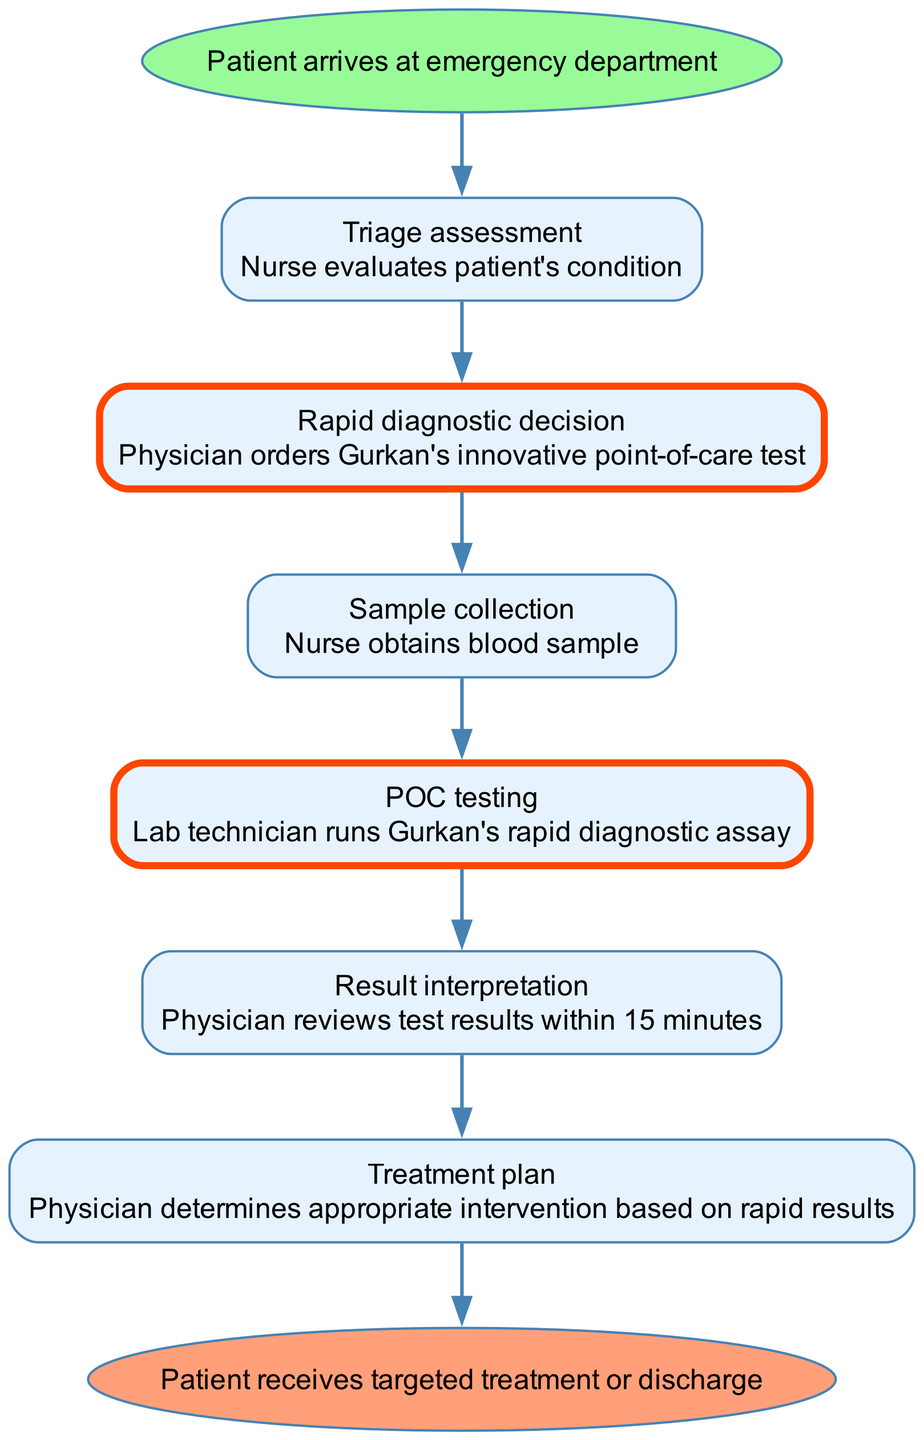What is the first step in the clinical pathway? The first step listed in the diagram is "Triage assessment," which follows the initial event of the patient arriving at the emergency department.
Answer: Triage assessment How many steps are there in the pathway? By counting the steps outlined in the pathway, we see there are a total of 6 steps before the patient receives targeted treatment or discharge.
Answer: 6 What does the lab technician do in the clinical pathway? The lab technician performs "POC testing" where they run Gurkan's rapid diagnostic assay on the blood sample collected.
Answer: POC testing Which step includes Gurkan's innovative test? The step titled "Rapid diagnostic decision" specifically mentions that the physician orders Gurkan's innovative point-of-care test as part of the workflow.
Answer: Rapid diagnostic decision After the result interpretation, what is the subsequent action taken by the physician? The next action after interpreting the results is for the physician to formulate a "Treatment plan" based on the rapid results obtained from the test.
Answer: Treatment plan How long does it take for the physician to review test results? The pathway indicates that the physician reviews the test results within 15 minutes during the "Result interpretation" step.
Answer: 15 minutes What is the ending outcome of this clinical pathway? The end node clearly states that the outcome is either the patient receiving targeted treatment or being discharged after the clinical process.
Answer: Patient receives targeted treatment or discharge Which step is associated with a nurse obtaining a blood sample? The step where the nurse obtains a blood sample is specifically labeled "Sample collection" in the workflow.
Answer: Sample collection 